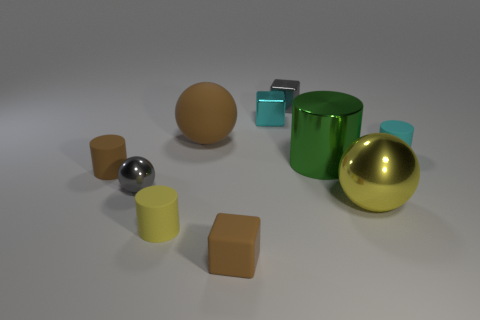Is the small gray object on the right side of the cyan metal cube made of the same material as the large ball that is left of the gray block?
Keep it short and to the point. No. There is a brown matte block that is on the right side of the tiny metallic thing that is in front of the brown cylinder; how big is it?
Offer a very short reply. Small. Are there any other small matte balls of the same color as the small ball?
Ensure brevity in your answer.  No. Does the block that is in front of the big brown object have the same color as the small matte cylinder that is to the right of the small yellow matte thing?
Give a very brief answer. No. There is a large green metallic thing; what shape is it?
Provide a short and direct response. Cylinder. There is a large brown sphere; what number of cyan metal cubes are on the left side of it?
Your answer should be very brief. 0. What number of other tiny cyan blocks are made of the same material as the cyan cube?
Ensure brevity in your answer.  0. Is the tiny thing that is in front of the yellow rubber cylinder made of the same material as the big cylinder?
Your response must be concise. No. Are there any large green cylinders?
Give a very brief answer. Yes. What is the size of the thing that is left of the green thing and on the right side of the cyan metal thing?
Give a very brief answer. Small. 